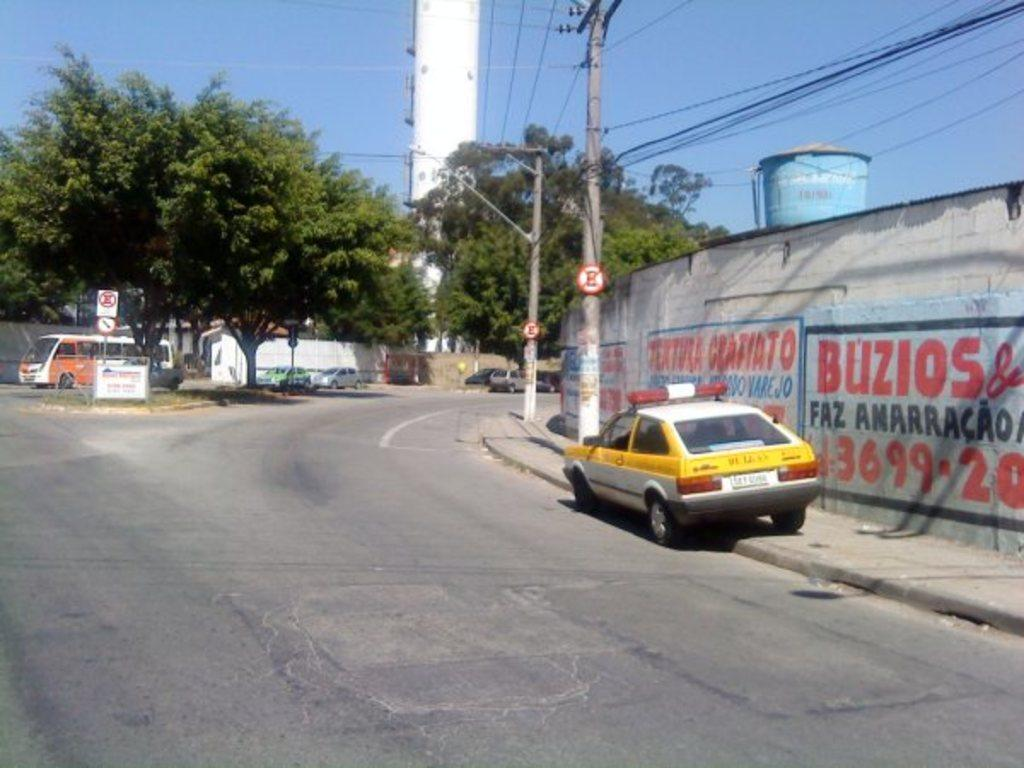<image>
Describe the image concisely. A white and yellow car near a wall with red lettering, the numbers 3699 are visible. 